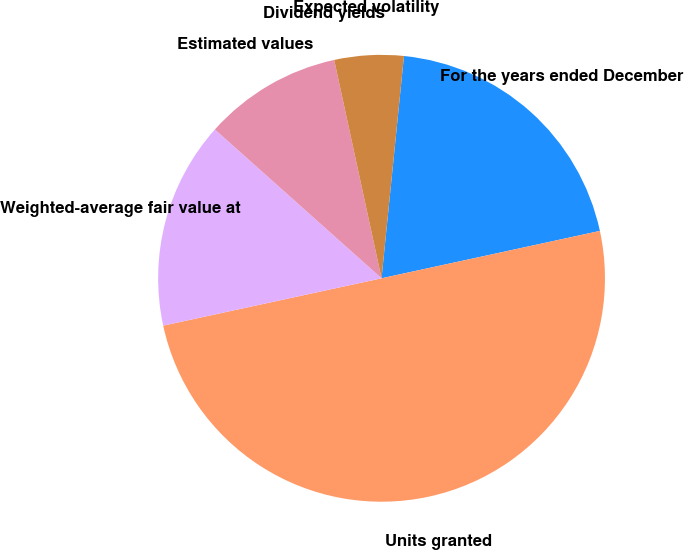<chart> <loc_0><loc_0><loc_500><loc_500><pie_chart><fcel>For the years ended December<fcel>Units granted<fcel>Weighted-average fair value at<fcel>Estimated values<fcel>Dividend yields<fcel>Expected volatility<nl><fcel>20.0%<fcel>50.0%<fcel>15.0%<fcel>10.0%<fcel>0.0%<fcel>5.0%<nl></chart> 